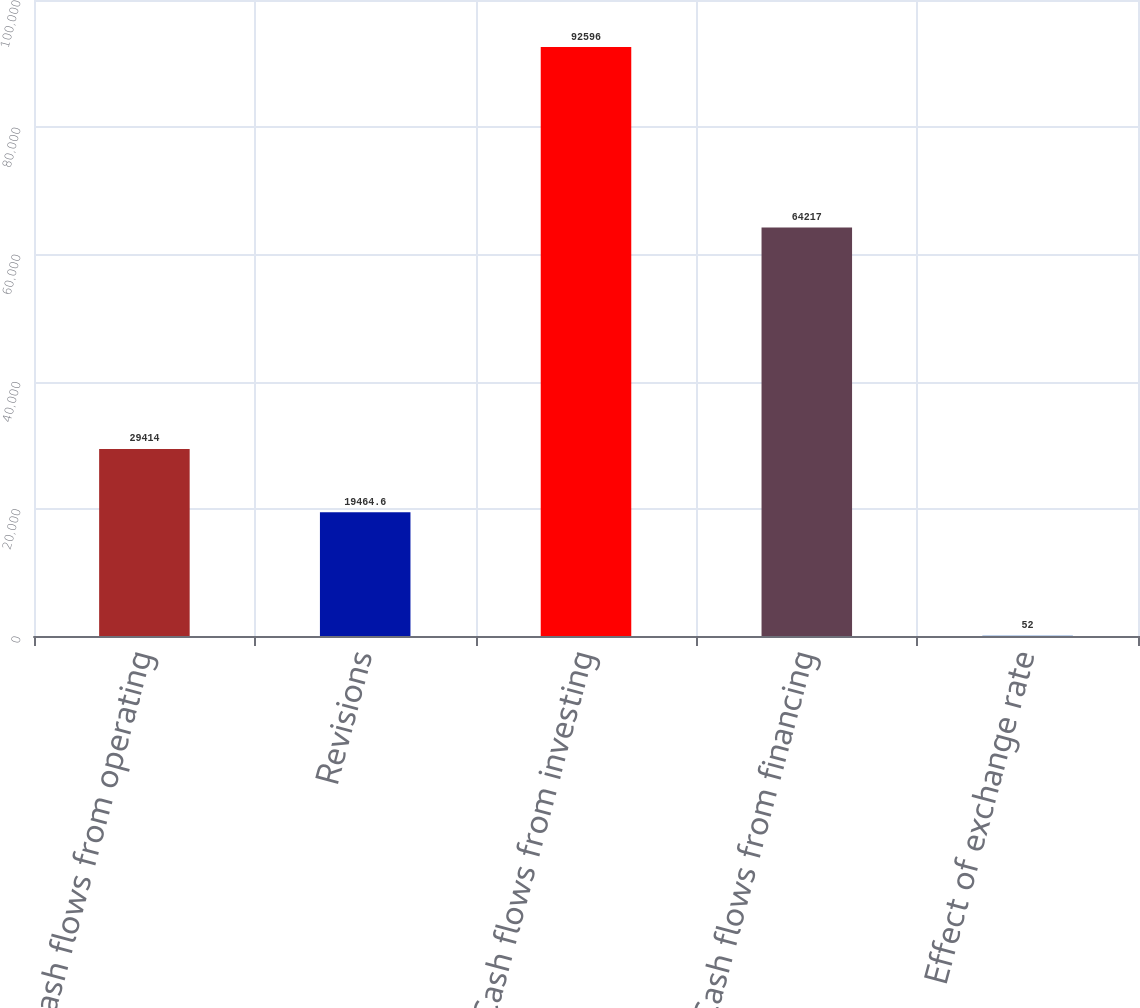Convert chart to OTSL. <chart><loc_0><loc_0><loc_500><loc_500><bar_chart><fcel>Cash flows from operating<fcel>Revisions<fcel>Cash flows from investing<fcel>Cash flows from financing<fcel>Effect of exchange rate<nl><fcel>29414<fcel>19464.6<fcel>92596<fcel>64217<fcel>52<nl></chart> 